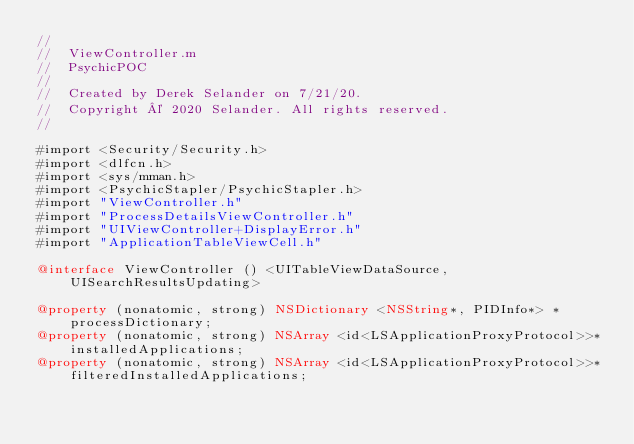Convert code to text. <code><loc_0><loc_0><loc_500><loc_500><_ObjectiveC_>//
//  ViewController.m
//  PsychicPOC
//
//  Created by Derek Selander on 7/21/20.
//  Copyright © 2020 Selander. All rights reserved.
//

#import <Security/Security.h>
#import <dlfcn.h>
#import <sys/mman.h>
#import <PsychicStapler/PsychicStapler.h>
#import "ViewController.h"
#import "ProcessDetailsViewController.h"
#import "UIViewController+DisplayError.h"
#import "ApplicationTableViewCell.h"

@interface ViewController () <UITableViewDataSource,  UISearchResultsUpdating>

@property (nonatomic, strong) NSDictionary <NSString*, PIDInfo*> *processDictionary;
@property (nonatomic, strong) NSArray <id<LSApplicationProxyProtocol>>*installedApplications;
@property (nonatomic, strong) NSArray <id<LSApplicationProxyProtocol>>* filteredInstalledApplications;</code> 